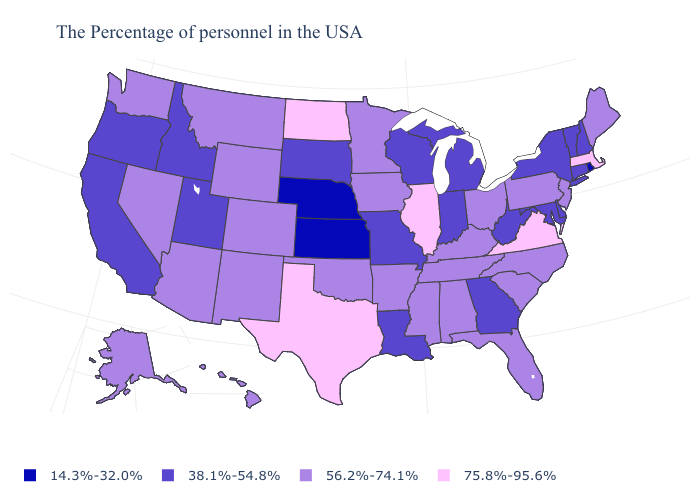What is the value of Colorado?
Answer briefly. 56.2%-74.1%. What is the value of Massachusetts?
Be succinct. 75.8%-95.6%. Name the states that have a value in the range 75.8%-95.6%?
Keep it brief. Massachusetts, Virginia, Illinois, Texas, North Dakota. What is the value of Alaska?
Short answer required. 56.2%-74.1%. How many symbols are there in the legend?
Give a very brief answer. 4. Among the states that border Colorado , which have the lowest value?
Be succinct. Kansas, Nebraska. Name the states that have a value in the range 56.2%-74.1%?
Quick response, please. Maine, New Jersey, Pennsylvania, North Carolina, South Carolina, Ohio, Florida, Kentucky, Alabama, Tennessee, Mississippi, Arkansas, Minnesota, Iowa, Oklahoma, Wyoming, Colorado, New Mexico, Montana, Arizona, Nevada, Washington, Alaska, Hawaii. Which states have the lowest value in the MidWest?
Concise answer only. Kansas, Nebraska. Which states have the lowest value in the South?
Quick response, please. Delaware, Maryland, West Virginia, Georgia, Louisiana. What is the value of New Mexico?
Concise answer only. 56.2%-74.1%. What is the value of South Carolina?
Give a very brief answer. 56.2%-74.1%. What is the lowest value in the USA?
Be succinct. 14.3%-32.0%. What is the value of Utah?
Keep it brief. 38.1%-54.8%. Does Texas have the highest value in the USA?
Keep it brief. Yes. Among the states that border North Carolina , does Georgia have the lowest value?
Short answer required. Yes. 